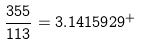<formula> <loc_0><loc_0><loc_500><loc_500>\frac { 3 5 5 } { 1 1 3 } = 3 . 1 4 1 5 9 2 9 ^ { + }</formula> 